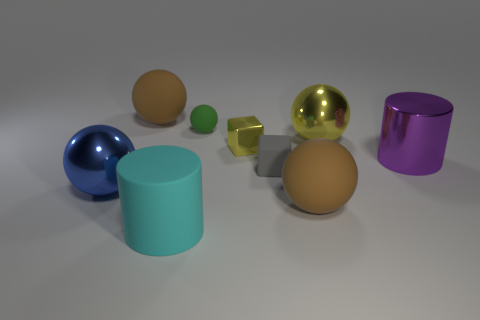Subtract all big yellow shiny spheres. How many spheres are left? 4 Subtract all blue spheres. How many spheres are left? 4 Subtract all yellow balls. Subtract all purple cylinders. How many balls are left? 4 Subtract all blocks. How many objects are left? 7 Add 3 large rubber balls. How many large rubber balls are left? 5 Add 2 brown rubber spheres. How many brown rubber spheres exist? 4 Subtract 0 brown blocks. How many objects are left? 9 Subtract all large cyan objects. Subtract all brown objects. How many objects are left? 6 